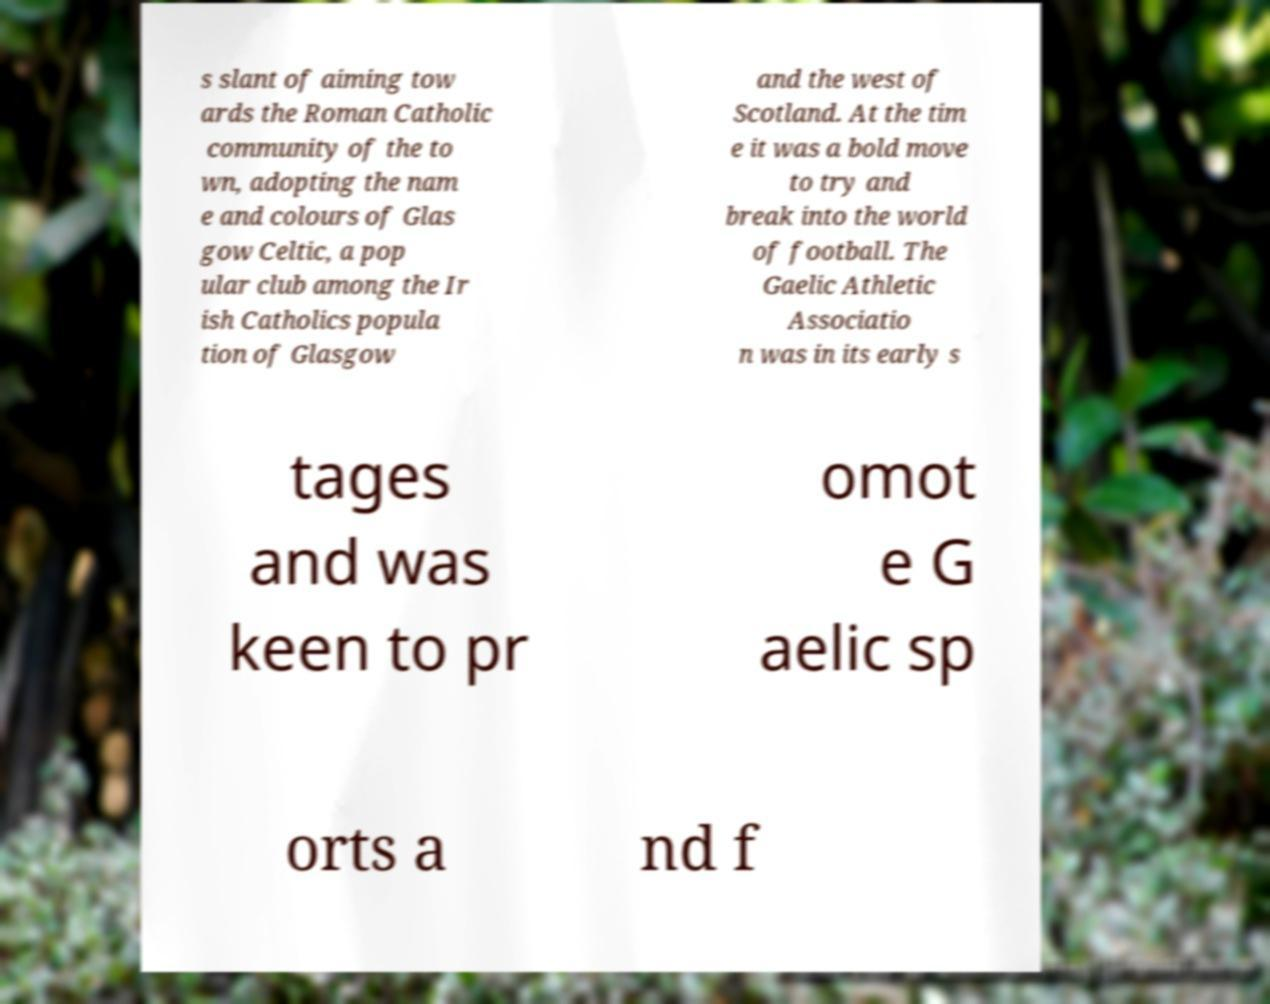What messages or text are displayed in this image? I need them in a readable, typed format. s slant of aiming tow ards the Roman Catholic community of the to wn, adopting the nam e and colours of Glas gow Celtic, a pop ular club among the Ir ish Catholics popula tion of Glasgow and the west of Scotland. At the tim e it was a bold move to try and break into the world of football. The Gaelic Athletic Associatio n was in its early s tages and was keen to pr omot e G aelic sp orts a nd f 